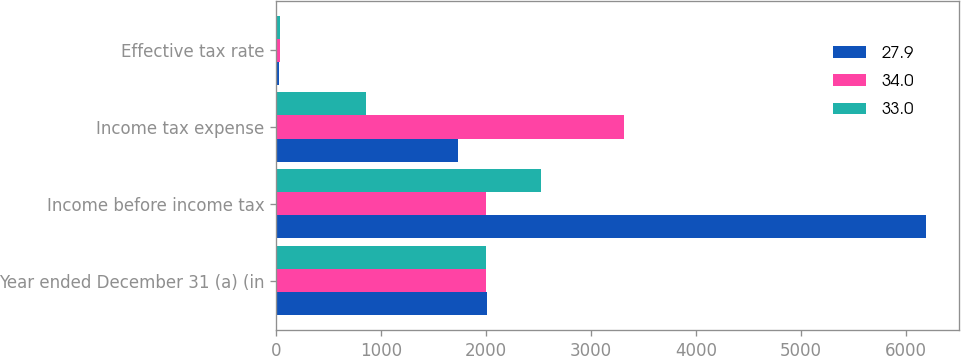Convert chart to OTSL. <chart><loc_0><loc_0><loc_500><loc_500><stacked_bar_chart><ecel><fcel>Year ended December 31 (a) (in<fcel>Income before income tax<fcel>Income tax expense<fcel>Effective tax rate<nl><fcel>27.9<fcel>2004<fcel>6194<fcel>1728<fcel>27.9<nl><fcel>34<fcel>2003<fcel>2002<fcel>3309<fcel>33<nl><fcel>33<fcel>2002<fcel>2519<fcel>856<fcel>34<nl></chart> 